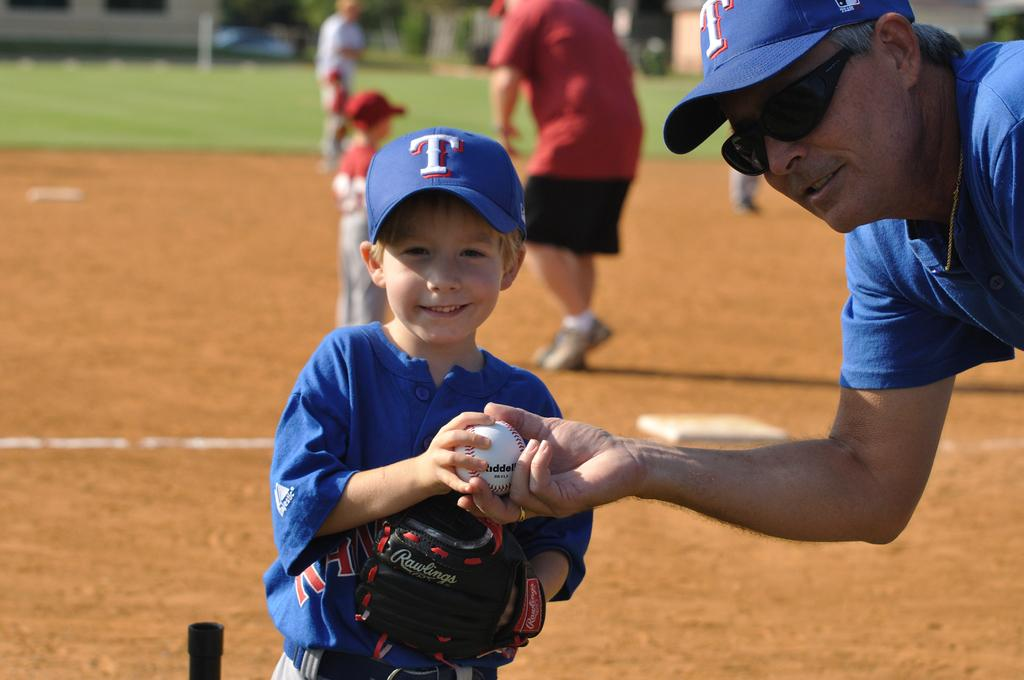<image>
Render a clear and concise summary of the photo. A man hands a small boy a baseball and both have the letter T on their caps 